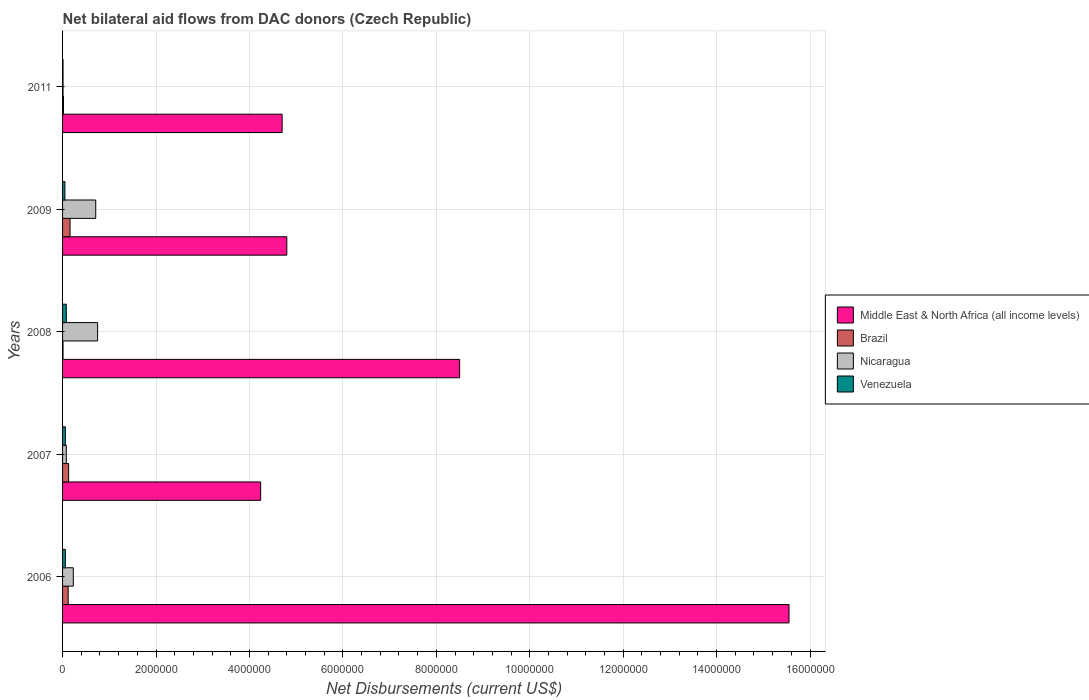Are the number of bars on each tick of the Y-axis equal?
Provide a short and direct response. Yes. How many bars are there on the 2nd tick from the bottom?
Your answer should be very brief. 4. What is the label of the 2nd group of bars from the top?
Offer a terse response. 2009. Across all years, what is the minimum net bilateral aid flows in Venezuela?
Keep it short and to the point. 10000. In which year was the net bilateral aid flows in Brazil maximum?
Keep it short and to the point. 2009. What is the total net bilateral aid flows in Middle East & North Africa (all income levels) in the graph?
Ensure brevity in your answer.  3.78e+07. What is the difference between the net bilateral aid flows in Middle East & North Africa (all income levels) in 2006 and the net bilateral aid flows in Brazil in 2011?
Provide a short and direct response. 1.55e+07. What is the average net bilateral aid flows in Brazil per year?
Offer a terse response. 8.80e+04. In the year 2007, what is the difference between the net bilateral aid flows in Venezuela and net bilateral aid flows in Middle East & North Africa (all income levels)?
Your answer should be compact. -4.18e+06. In how many years, is the net bilateral aid flows in Nicaragua greater than 6400000 US$?
Your answer should be compact. 0. What is the ratio of the net bilateral aid flows in Venezuela in 2009 to that in 2011?
Provide a succinct answer. 5. Is the net bilateral aid flows in Nicaragua in 2006 less than that in 2009?
Offer a very short reply. Yes. Is the difference between the net bilateral aid flows in Venezuela in 2008 and 2009 greater than the difference between the net bilateral aid flows in Middle East & North Africa (all income levels) in 2008 and 2009?
Offer a very short reply. No. What is the difference between the highest and the second highest net bilateral aid flows in Middle East & North Africa (all income levels)?
Your answer should be very brief. 7.05e+06. Is the sum of the net bilateral aid flows in Nicaragua in 2006 and 2007 greater than the maximum net bilateral aid flows in Venezuela across all years?
Offer a very short reply. Yes. What does the 4th bar from the top in 2006 represents?
Give a very brief answer. Middle East & North Africa (all income levels). What does the 4th bar from the bottom in 2011 represents?
Your answer should be very brief. Venezuela. Are all the bars in the graph horizontal?
Make the answer very short. Yes. How many years are there in the graph?
Offer a very short reply. 5. Are the values on the major ticks of X-axis written in scientific E-notation?
Provide a short and direct response. No. Does the graph contain grids?
Give a very brief answer. Yes. How many legend labels are there?
Make the answer very short. 4. How are the legend labels stacked?
Offer a very short reply. Vertical. What is the title of the graph?
Your response must be concise. Net bilateral aid flows from DAC donors (Czech Republic). What is the label or title of the X-axis?
Provide a succinct answer. Net Disbursements (current US$). What is the label or title of the Y-axis?
Offer a terse response. Years. What is the Net Disbursements (current US$) in Middle East & North Africa (all income levels) in 2006?
Provide a short and direct response. 1.56e+07. What is the Net Disbursements (current US$) of Brazil in 2006?
Your answer should be very brief. 1.20e+05. What is the Net Disbursements (current US$) in Nicaragua in 2006?
Offer a very short reply. 2.30e+05. What is the Net Disbursements (current US$) in Middle East & North Africa (all income levels) in 2007?
Your answer should be very brief. 4.24e+06. What is the Net Disbursements (current US$) in Brazil in 2007?
Provide a short and direct response. 1.30e+05. What is the Net Disbursements (current US$) in Nicaragua in 2007?
Offer a terse response. 8.00e+04. What is the Net Disbursements (current US$) in Venezuela in 2007?
Your answer should be very brief. 6.00e+04. What is the Net Disbursements (current US$) in Middle East & North Africa (all income levels) in 2008?
Give a very brief answer. 8.50e+06. What is the Net Disbursements (current US$) in Nicaragua in 2008?
Your answer should be compact. 7.50e+05. What is the Net Disbursements (current US$) of Venezuela in 2008?
Offer a terse response. 8.00e+04. What is the Net Disbursements (current US$) of Middle East & North Africa (all income levels) in 2009?
Your answer should be compact. 4.80e+06. What is the Net Disbursements (current US$) of Nicaragua in 2009?
Offer a terse response. 7.10e+05. What is the Net Disbursements (current US$) in Venezuela in 2009?
Ensure brevity in your answer.  5.00e+04. What is the Net Disbursements (current US$) of Middle East & North Africa (all income levels) in 2011?
Keep it short and to the point. 4.70e+06. What is the Net Disbursements (current US$) of Venezuela in 2011?
Offer a terse response. 10000. Across all years, what is the maximum Net Disbursements (current US$) of Middle East & North Africa (all income levels)?
Your response must be concise. 1.56e+07. Across all years, what is the maximum Net Disbursements (current US$) in Brazil?
Ensure brevity in your answer.  1.60e+05. Across all years, what is the maximum Net Disbursements (current US$) of Nicaragua?
Your answer should be very brief. 7.50e+05. Across all years, what is the maximum Net Disbursements (current US$) of Venezuela?
Provide a short and direct response. 8.00e+04. Across all years, what is the minimum Net Disbursements (current US$) of Middle East & North Africa (all income levels)?
Offer a very short reply. 4.24e+06. What is the total Net Disbursements (current US$) of Middle East & North Africa (all income levels) in the graph?
Your answer should be very brief. 3.78e+07. What is the total Net Disbursements (current US$) of Brazil in the graph?
Provide a succinct answer. 4.40e+05. What is the total Net Disbursements (current US$) in Nicaragua in the graph?
Make the answer very short. 1.78e+06. What is the difference between the Net Disbursements (current US$) of Middle East & North Africa (all income levels) in 2006 and that in 2007?
Your answer should be compact. 1.13e+07. What is the difference between the Net Disbursements (current US$) in Middle East & North Africa (all income levels) in 2006 and that in 2008?
Your response must be concise. 7.05e+06. What is the difference between the Net Disbursements (current US$) of Nicaragua in 2006 and that in 2008?
Offer a terse response. -5.20e+05. What is the difference between the Net Disbursements (current US$) of Venezuela in 2006 and that in 2008?
Your answer should be very brief. -2.00e+04. What is the difference between the Net Disbursements (current US$) in Middle East & North Africa (all income levels) in 2006 and that in 2009?
Provide a succinct answer. 1.08e+07. What is the difference between the Net Disbursements (current US$) of Brazil in 2006 and that in 2009?
Make the answer very short. -4.00e+04. What is the difference between the Net Disbursements (current US$) in Nicaragua in 2006 and that in 2009?
Provide a short and direct response. -4.80e+05. What is the difference between the Net Disbursements (current US$) in Venezuela in 2006 and that in 2009?
Your response must be concise. 10000. What is the difference between the Net Disbursements (current US$) of Middle East & North Africa (all income levels) in 2006 and that in 2011?
Provide a succinct answer. 1.08e+07. What is the difference between the Net Disbursements (current US$) of Brazil in 2006 and that in 2011?
Provide a short and direct response. 1.00e+05. What is the difference between the Net Disbursements (current US$) of Nicaragua in 2006 and that in 2011?
Provide a succinct answer. 2.20e+05. What is the difference between the Net Disbursements (current US$) of Venezuela in 2006 and that in 2011?
Your answer should be very brief. 5.00e+04. What is the difference between the Net Disbursements (current US$) in Middle East & North Africa (all income levels) in 2007 and that in 2008?
Offer a very short reply. -4.26e+06. What is the difference between the Net Disbursements (current US$) in Brazil in 2007 and that in 2008?
Provide a short and direct response. 1.20e+05. What is the difference between the Net Disbursements (current US$) in Nicaragua in 2007 and that in 2008?
Ensure brevity in your answer.  -6.70e+05. What is the difference between the Net Disbursements (current US$) of Middle East & North Africa (all income levels) in 2007 and that in 2009?
Offer a terse response. -5.60e+05. What is the difference between the Net Disbursements (current US$) of Nicaragua in 2007 and that in 2009?
Provide a short and direct response. -6.30e+05. What is the difference between the Net Disbursements (current US$) of Middle East & North Africa (all income levels) in 2007 and that in 2011?
Your answer should be compact. -4.60e+05. What is the difference between the Net Disbursements (current US$) of Venezuela in 2007 and that in 2011?
Offer a terse response. 5.00e+04. What is the difference between the Net Disbursements (current US$) of Middle East & North Africa (all income levels) in 2008 and that in 2009?
Provide a succinct answer. 3.70e+06. What is the difference between the Net Disbursements (current US$) of Middle East & North Africa (all income levels) in 2008 and that in 2011?
Your answer should be compact. 3.80e+06. What is the difference between the Net Disbursements (current US$) of Nicaragua in 2008 and that in 2011?
Keep it short and to the point. 7.40e+05. What is the difference between the Net Disbursements (current US$) of Middle East & North Africa (all income levels) in 2009 and that in 2011?
Your response must be concise. 1.00e+05. What is the difference between the Net Disbursements (current US$) of Venezuela in 2009 and that in 2011?
Your response must be concise. 4.00e+04. What is the difference between the Net Disbursements (current US$) in Middle East & North Africa (all income levels) in 2006 and the Net Disbursements (current US$) in Brazil in 2007?
Ensure brevity in your answer.  1.54e+07. What is the difference between the Net Disbursements (current US$) in Middle East & North Africa (all income levels) in 2006 and the Net Disbursements (current US$) in Nicaragua in 2007?
Your answer should be very brief. 1.55e+07. What is the difference between the Net Disbursements (current US$) in Middle East & North Africa (all income levels) in 2006 and the Net Disbursements (current US$) in Venezuela in 2007?
Offer a terse response. 1.55e+07. What is the difference between the Net Disbursements (current US$) in Brazil in 2006 and the Net Disbursements (current US$) in Venezuela in 2007?
Your answer should be compact. 6.00e+04. What is the difference between the Net Disbursements (current US$) in Nicaragua in 2006 and the Net Disbursements (current US$) in Venezuela in 2007?
Provide a succinct answer. 1.70e+05. What is the difference between the Net Disbursements (current US$) in Middle East & North Africa (all income levels) in 2006 and the Net Disbursements (current US$) in Brazil in 2008?
Offer a very short reply. 1.55e+07. What is the difference between the Net Disbursements (current US$) of Middle East & North Africa (all income levels) in 2006 and the Net Disbursements (current US$) of Nicaragua in 2008?
Ensure brevity in your answer.  1.48e+07. What is the difference between the Net Disbursements (current US$) in Middle East & North Africa (all income levels) in 2006 and the Net Disbursements (current US$) in Venezuela in 2008?
Offer a terse response. 1.55e+07. What is the difference between the Net Disbursements (current US$) in Brazil in 2006 and the Net Disbursements (current US$) in Nicaragua in 2008?
Offer a very short reply. -6.30e+05. What is the difference between the Net Disbursements (current US$) of Middle East & North Africa (all income levels) in 2006 and the Net Disbursements (current US$) of Brazil in 2009?
Offer a very short reply. 1.54e+07. What is the difference between the Net Disbursements (current US$) in Middle East & North Africa (all income levels) in 2006 and the Net Disbursements (current US$) in Nicaragua in 2009?
Your answer should be compact. 1.48e+07. What is the difference between the Net Disbursements (current US$) in Middle East & North Africa (all income levels) in 2006 and the Net Disbursements (current US$) in Venezuela in 2009?
Provide a succinct answer. 1.55e+07. What is the difference between the Net Disbursements (current US$) of Brazil in 2006 and the Net Disbursements (current US$) of Nicaragua in 2009?
Your answer should be compact. -5.90e+05. What is the difference between the Net Disbursements (current US$) of Middle East & North Africa (all income levels) in 2006 and the Net Disbursements (current US$) of Brazil in 2011?
Offer a very short reply. 1.55e+07. What is the difference between the Net Disbursements (current US$) in Middle East & North Africa (all income levels) in 2006 and the Net Disbursements (current US$) in Nicaragua in 2011?
Ensure brevity in your answer.  1.55e+07. What is the difference between the Net Disbursements (current US$) in Middle East & North Africa (all income levels) in 2006 and the Net Disbursements (current US$) in Venezuela in 2011?
Offer a terse response. 1.55e+07. What is the difference between the Net Disbursements (current US$) of Nicaragua in 2006 and the Net Disbursements (current US$) of Venezuela in 2011?
Provide a short and direct response. 2.20e+05. What is the difference between the Net Disbursements (current US$) of Middle East & North Africa (all income levels) in 2007 and the Net Disbursements (current US$) of Brazil in 2008?
Provide a short and direct response. 4.23e+06. What is the difference between the Net Disbursements (current US$) in Middle East & North Africa (all income levels) in 2007 and the Net Disbursements (current US$) in Nicaragua in 2008?
Ensure brevity in your answer.  3.49e+06. What is the difference between the Net Disbursements (current US$) in Middle East & North Africa (all income levels) in 2007 and the Net Disbursements (current US$) in Venezuela in 2008?
Give a very brief answer. 4.16e+06. What is the difference between the Net Disbursements (current US$) in Brazil in 2007 and the Net Disbursements (current US$) in Nicaragua in 2008?
Ensure brevity in your answer.  -6.20e+05. What is the difference between the Net Disbursements (current US$) in Brazil in 2007 and the Net Disbursements (current US$) in Venezuela in 2008?
Offer a very short reply. 5.00e+04. What is the difference between the Net Disbursements (current US$) of Middle East & North Africa (all income levels) in 2007 and the Net Disbursements (current US$) of Brazil in 2009?
Provide a succinct answer. 4.08e+06. What is the difference between the Net Disbursements (current US$) of Middle East & North Africa (all income levels) in 2007 and the Net Disbursements (current US$) of Nicaragua in 2009?
Ensure brevity in your answer.  3.53e+06. What is the difference between the Net Disbursements (current US$) of Middle East & North Africa (all income levels) in 2007 and the Net Disbursements (current US$) of Venezuela in 2009?
Your answer should be very brief. 4.19e+06. What is the difference between the Net Disbursements (current US$) in Brazil in 2007 and the Net Disbursements (current US$) in Nicaragua in 2009?
Offer a very short reply. -5.80e+05. What is the difference between the Net Disbursements (current US$) in Nicaragua in 2007 and the Net Disbursements (current US$) in Venezuela in 2009?
Provide a succinct answer. 3.00e+04. What is the difference between the Net Disbursements (current US$) in Middle East & North Africa (all income levels) in 2007 and the Net Disbursements (current US$) in Brazil in 2011?
Provide a succinct answer. 4.22e+06. What is the difference between the Net Disbursements (current US$) of Middle East & North Africa (all income levels) in 2007 and the Net Disbursements (current US$) of Nicaragua in 2011?
Your response must be concise. 4.23e+06. What is the difference between the Net Disbursements (current US$) in Middle East & North Africa (all income levels) in 2007 and the Net Disbursements (current US$) in Venezuela in 2011?
Provide a succinct answer. 4.23e+06. What is the difference between the Net Disbursements (current US$) in Brazil in 2007 and the Net Disbursements (current US$) in Venezuela in 2011?
Your answer should be very brief. 1.20e+05. What is the difference between the Net Disbursements (current US$) of Nicaragua in 2007 and the Net Disbursements (current US$) of Venezuela in 2011?
Your answer should be very brief. 7.00e+04. What is the difference between the Net Disbursements (current US$) in Middle East & North Africa (all income levels) in 2008 and the Net Disbursements (current US$) in Brazil in 2009?
Your answer should be compact. 8.34e+06. What is the difference between the Net Disbursements (current US$) of Middle East & North Africa (all income levels) in 2008 and the Net Disbursements (current US$) of Nicaragua in 2009?
Offer a terse response. 7.79e+06. What is the difference between the Net Disbursements (current US$) of Middle East & North Africa (all income levels) in 2008 and the Net Disbursements (current US$) of Venezuela in 2009?
Provide a short and direct response. 8.45e+06. What is the difference between the Net Disbursements (current US$) of Brazil in 2008 and the Net Disbursements (current US$) of Nicaragua in 2009?
Make the answer very short. -7.00e+05. What is the difference between the Net Disbursements (current US$) in Nicaragua in 2008 and the Net Disbursements (current US$) in Venezuela in 2009?
Ensure brevity in your answer.  7.00e+05. What is the difference between the Net Disbursements (current US$) of Middle East & North Africa (all income levels) in 2008 and the Net Disbursements (current US$) of Brazil in 2011?
Offer a very short reply. 8.48e+06. What is the difference between the Net Disbursements (current US$) in Middle East & North Africa (all income levels) in 2008 and the Net Disbursements (current US$) in Nicaragua in 2011?
Provide a short and direct response. 8.49e+06. What is the difference between the Net Disbursements (current US$) of Middle East & North Africa (all income levels) in 2008 and the Net Disbursements (current US$) of Venezuela in 2011?
Your answer should be compact. 8.49e+06. What is the difference between the Net Disbursements (current US$) in Brazil in 2008 and the Net Disbursements (current US$) in Nicaragua in 2011?
Offer a terse response. 0. What is the difference between the Net Disbursements (current US$) in Brazil in 2008 and the Net Disbursements (current US$) in Venezuela in 2011?
Make the answer very short. 0. What is the difference between the Net Disbursements (current US$) in Nicaragua in 2008 and the Net Disbursements (current US$) in Venezuela in 2011?
Offer a very short reply. 7.40e+05. What is the difference between the Net Disbursements (current US$) of Middle East & North Africa (all income levels) in 2009 and the Net Disbursements (current US$) of Brazil in 2011?
Give a very brief answer. 4.78e+06. What is the difference between the Net Disbursements (current US$) of Middle East & North Africa (all income levels) in 2009 and the Net Disbursements (current US$) of Nicaragua in 2011?
Keep it short and to the point. 4.79e+06. What is the difference between the Net Disbursements (current US$) in Middle East & North Africa (all income levels) in 2009 and the Net Disbursements (current US$) in Venezuela in 2011?
Offer a very short reply. 4.79e+06. What is the difference between the Net Disbursements (current US$) in Nicaragua in 2009 and the Net Disbursements (current US$) in Venezuela in 2011?
Give a very brief answer. 7.00e+05. What is the average Net Disbursements (current US$) in Middle East & North Africa (all income levels) per year?
Offer a terse response. 7.56e+06. What is the average Net Disbursements (current US$) of Brazil per year?
Your answer should be compact. 8.80e+04. What is the average Net Disbursements (current US$) of Nicaragua per year?
Keep it short and to the point. 3.56e+05. What is the average Net Disbursements (current US$) in Venezuela per year?
Keep it short and to the point. 5.20e+04. In the year 2006, what is the difference between the Net Disbursements (current US$) of Middle East & North Africa (all income levels) and Net Disbursements (current US$) of Brazil?
Your answer should be very brief. 1.54e+07. In the year 2006, what is the difference between the Net Disbursements (current US$) of Middle East & North Africa (all income levels) and Net Disbursements (current US$) of Nicaragua?
Your answer should be very brief. 1.53e+07. In the year 2006, what is the difference between the Net Disbursements (current US$) of Middle East & North Africa (all income levels) and Net Disbursements (current US$) of Venezuela?
Provide a short and direct response. 1.55e+07. In the year 2006, what is the difference between the Net Disbursements (current US$) of Brazil and Net Disbursements (current US$) of Nicaragua?
Offer a very short reply. -1.10e+05. In the year 2006, what is the difference between the Net Disbursements (current US$) of Nicaragua and Net Disbursements (current US$) of Venezuela?
Offer a very short reply. 1.70e+05. In the year 2007, what is the difference between the Net Disbursements (current US$) of Middle East & North Africa (all income levels) and Net Disbursements (current US$) of Brazil?
Provide a succinct answer. 4.11e+06. In the year 2007, what is the difference between the Net Disbursements (current US$) in Middle East & North Africa (all income levels) and Net Disbursements (current US$) in Nicaragua?
Provide a short and direct response. 4.16e+06. In the year 2007, what is the difference between the Net Disbursements (current US$) of Middle East & North Africa (all income levels) and Net Disbursements (current US$) of Venezuela?
Provide a short and direct response. 4.18e+06. In the year 2007, what is the difference between the Net Disbursements (current US$) of Brazil and Net Disbursements (current US$) of Nicaragua?
Your response must be concise. 5.00e+04. In the year 2007, what is the difference between the Net Disbursements (current US$) in Brazil and Net Disbursements (current US$) in Venezuela?
Your answer should be compact. 7.00e+04. In the year 2007, what is the difference between the Net Disbursements (current US$) of Nicaragua and Net Disbursements (current US$) of Venezuela?
Ensure brevity in your answer.  2.00e+04. In the year 2008, what is the difference between the Net Disbursements (current US$) in Middle East & North Africa (all income levels) and Net Disbursements (current US$) in Brazil?
Make the answer very short. 8.49e+06. In the year 2008, what is the difference between the Net Disbursements (current US$) in Middle East & North Africa (all income levels) and Net Disbursements (current US$) in Nicaragua?
Your response must be concise. 7.75e+06. In the year 2008, what is the difference between the Net Disbursements (current US$) of Middle East & North Africa (all income levels) and Net Disbursements (current US$) of Venezuela?
Keep it short and to the point. 8.42e+06. In the year 2008, what is the difference between the Net Disbursements (current US$) of Brazil and Net Disbursements (current US$) of Nicaragua?
Provide a short and direct response. -7.40e+05. In the year 2008, what is the difference between the Net Disbursements (current US$) in Nicaragua and Net Disbursements (current US$) in Venezuela?
Provide a succinct answer. 6.70e+05. In the year 2009, what is the difference between the Net Disbursements (current US$) of Middle East & North Africa (all income levels) and Net Disbursements (current US$) of Brazil?
Provide a short and direct response. 4.64e+06. In the year 2009, what is the difference between the Net Disbursements (current US$) in Middle East & North Africa (all income levels) and Net Disbursements (current US$) in Nicaragua?
Your answer should be compact. 4.09e+06. In the year 2009, what is the difference between the Net Disbursements (current US$) in Middle East & North Africa (all income levels) and Net Disbursements (current US$) in Venezuela?
Your answer should be very brief. 4.75e+06. In the year 2009, what is the difference between the Net Disbursements (current US$) of Brazil and Net Disbursements (current US$) of Nicaragua?
Your answer should be very brief. -5.50e+05. In the year 2009, what is the difference between the Net Disbursements (current US$) in Nicaragua and Net Disbursements (current US$) in Venezuela?
Your answer should be compact. 6.60e+05. In the year 2011, what is the difference between the Net Disbursements (current US$) of Middle East & North Africa (all income levels) and Net Disbursements (current US$) of Brazil?
Keep it short and to the point. 4.68e+06. In the year 2011, what is the difference between the Net Disbursements (current US$) in Middle East & North Africa (all income levels) and Net Disbursements (current US$) in Nicaragua?
Provide a succinct answer. 4.69e+06. In the year 2011, what is the difference between the Net Disbursements (current US$) in Middle East & North Africa (all income levels) and Net Disbursements (current US$) in Venezuela?
Your response must be concise. 4.69e+06. In the year 2011, what is the difference between the Net Disbursements (current US$) of Brazil and Net Disbursements (current US$) of Nicaragua?
Make the answer very short. 10000. In the year 2011, what is the difference between the Net Disbursements (current US$) in Brazil and Net Disbursements (current US$) in Venezuela?
Your response must be concise. 10000. What is the ratio of the Net Disbursements (current US$) in Middle East & North Africa (all income levels) in 2006 to that in 2007?
Give a very brief answer. 3.67. What is the ratio of the Net Disbursements (current US$) in Brazil in 2006 to that in 2007?
Your answer should be very brief. 0.92. What is the ratio of the Net Disbursements (current US$) in Nicaragua in 2006 to that in 2007?
Provide a short and direct response. 2.88. What is the ratio of the Net Disbursements (current US$) in Venezuela in 2006 to that in 2007?
Ensure brevity in your answer.  1. What is the ratio of the Net Disbursements (current US$) in Middle East & North Africa (all income levels) in 2006 to that in 2008?
Your response must be concise. 1.83. What is the ratio of the Net Disbursements (current US$) in Brazil in 2006 to that in 2008?
Your answer should be very brief. 12. What is the ratio of the Net Disbursements (current US$) in Nicaragua in 2006 to that in 2008?
Provide a short and direct response. 0.31. What is the ratio of the Net Disbursements (current US$) of Middle East & North Africa (all income levels) in 2006 to that in 2009?
Offer a terse response. 3.24. What is the ratio of the Net Disbursements (current US$) in Nicaragua in 2006 to that in 2009?
Offer a terse response. 0.32. What is the ratio of the Net Disbursements (current US$) in Venezuela in 2006 to that in 2009?
Your response must be concise. 1.2. What is the ratio of the Net Disbursements (current US$) in Middle East & North Africa (all income levels) in 2006 to that in 2011?
Offer a terse response. 3.31. What is the ratio of the Net Disbursements (current US$) of Brazil in 2006 to that in 2011?
Provide a succinct answer. 6. What is the ratio of the Net Disbursements (current US$) of Nicaragua in 2006 to that in 2011?
Give a very brief answer. 23. What is the ratio of the Net Disbursements (current US$) in Venezuela in 2006 to that in 2011?
Offer a terse response. 6. What is the ratio of the Net Disbursements (current US$) in Middle East & North Africa (all income levels) in 2007 to that in 2008?
Offer a terse response. 0.5. What is the ratio of the Net Disbursements (current US$) in Nicaragua in 2007 to that in 2008?
Give a very brief answer. 0.11. What is the ratio of the Net Disbursements (current US$) of Middle East & North Africa (all income levels) in 2007 to that in 2009?
Keep it short and to the point. 0.88. What is the ratio of the Net Disbursements (current US$) in Brazil in 2007 to that in 2009?
Your response must be concise. 0.81. What is the ratio of the Net Disbursements (current US$) of Nicaragua in 2007 to that in 2009?
Your answer should be very brief. 0.11. What is the ratio of the Net Disbursements (current US$) of Middle East & North Africa (all income levels) in 2007 to that in 2011?
Give a very brief answer. 0.9. What is the ratio of the Net Disbursements (current US$) in Middle East & North Africa (all income levels) in 2008 to that in 2009?
Your response must be concise. 1.77. What is the ratio of the Net Disbursements (current US$) in Brazil in 2008 to that in 2009?
Keep it short and to the point. 0.06. What is the ratio of the Net Disbursements (current US$) in Nicaragua in 2008 to that in 2009?
Your response must be concise. 1.06. What is the ratio of the Net Disbursements (current US$) of Venezuela in 2008 to that in 2009?
Ensure brevity in your answer.  1.6. What is the ratio of the Net Disbursements (current US$) of Middle East & North Africa (all income levels) in 2008 to that in 2011?
Your response must be concise. 1.81. What is the ratio of the Net Disbursements (current US$) of Brazil in 2008 to that in 2011?
Offer a terse response. 0.5. What is the ratio of the Net Disbursements (current US$) in Middle East & North Africa (all income levels) in 2009 to that in 2011?
Ensure brevity in your answer.  1.02. What is the ratio of the Net Disbursements (current US$) of Brazil in 2009 to that in 2011?
Offer a very short reply. 8. What is the ratio of the Net Disbursements (current US$) of Nicaragua in 2009 to that in 2011?
Your answer should be compact. 71. What is the ratio of the Net Disbursements (current US$) of Venezuela in 2009 to that in 2011?
Ensure brevity in your answer.  5. What is the difference between the highest and the second highest Net Disbursements (current US$) of Middle East & North Africa (all income levels)?
Your response must be concise. 7.05e+06. What is the difference between the highest and the second highest Net Disbursements (current US$) in Brazil?
Ensure brevity in your answer.  3.00e+04. What is the difference between the highest and the second highest Net Disbursements (current US$) of Nicaragua?
Ensure brevity in your answer.  4.00e+04. What is the difference between the highest and the second highest Net Disbursements (current US$) of Venezuela?
Your answer should be compact. 2.00e+04. What is the difference between the highest and the lowest Net Disbursements (current US$) in Middle East & North Africa (all income levels)?
Provide a succinct answer. 1.13e+07. What is the difference between the highest and the lowest Net Disbursements (current US$) of Brazil?
Give a very brief answer. 1.50e+05. What is the difference between the highest and the lowest Net Disbursements (current US$) in Nicaragua?
Your response must be concise. 7.40e+05. 